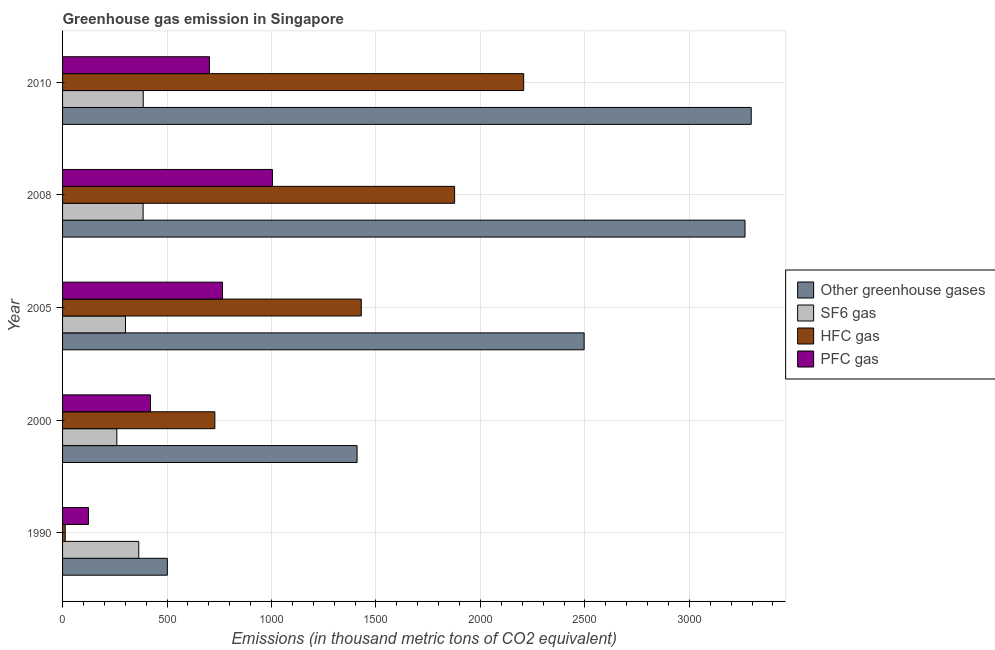How many different coloured bars are there?
Your answer should be very brief. 4. How many bars are there on the 4th tick from the bottom?
Your response must be concise. 4. What is the label of the 1st group of bars from the top?
Your answer should be very brief. 2010. In how many cases, is the number of bars for a given year not equal to the number of legend labels?
Your answer should be very brief. 0. What is the emission of hfc gas in 2008?
Offer a very short reply. 1876.4. Across all years, what is the maximum emission of pfc gas?
Provide a short and direct response. 1004.5. Across all years, what is the minimum emission of greenhouse gases?
Make the answer very short. 501.5. What is the total emission of hfc gas in the graph?
Your answer should be very brief. 6254.6. What is the difference between the emission of sf6 gas in 1990 and that in 2010?
Keep it short and to the point. -21.3. What is the difference between the emission of pfc gas in 2010 and the emission of hfc gas in 2008?
Your response must be concise. -1173.4. What is the average emission of sf6 gas per year?
Offer a terse response. 339.44. In the year 2008, what is the difference between the emission of greenhouse gases and emission of hfc gas?
Your response must be concise. 1390. In how many years, is the emission of sf6 gas greater than 2800 thousand metric tons?
Make the answer very short. 0. What is the ratio of the emission of hfc gas in 1990 to that in 2005?
Provide a succinct answer. 0.01. Is the difference between the emission of pfc gas in 2005 and 2008 greater than the difference between the emission of sf6 gas in 2005 and 2008?
Provide a succinct answer. No. What is the difference between the highest and the second highest emission of greenhouse gases?
Your answer should be very brief. 29.6. What is the difference between the highest and the lowest emission of greenhouse gases?
Your response must be concise. 2794.5. In how many years, is the emission of pfc gas greater than the average emission of pfc gas taken over all years?
Your answer should be very brief. 3. Is the sum of the emission of hfc gas in 2000 and 2010 greater than the maximum emission of sf6 gas across all years?
Provide a succinct answer. Yes. What does the 4th bar from the top in 2008 represents?
Provide a short and direct response. Other greenhouse gases. What does the 3rd bar from the bottom in 2005 represents?
Provide a succinct answer. HFC gas. Is it the case that in every year, the sum of the emission of greenhouse gases and emission of sf6 gas is greater than the emission of hfc gas?
Offer a very short reply. Yes. What is the title of the graph?
Keep it short and to the point. Greenhouse gas emission in Singapore. Does "WHO" appear as one of the legend labels in the graph?
Offer a terse response. No. What is the label or title of the X-axis?
Provide a succinct answer. Emissions (in thousand metric tons of CO2 equivalent). What is the Emissions (in thousand metric tons of CO2 equivalent) of Other greenhouse gases in 1990?
Your response must be concise. 501.5. What is the Emissions (in thousand metric tons of CO2 equivalent) of SF6 gas in 1990?
Offer a terse response. 364.7. What is the Emissions (in thousand metric tons of CO2 equivalent) of HFC gas in 1990?
Provide a short and direct response. 12.6. What is the Emissions (in thousand metric tons of CO2 equivalent) in PFC gas in 1990?
Your answer should be compact. 124.2. What is the Emissions (in thousand metric tons of CO2 equivalent) in Other greenhouse gases in 2000?
Keep it short and to the point. 1409.6. What is the Emissions (in thousand metric tons of CO2 equivalent) of SF6 gas in 2000?
Offer a terse response. 259.8. What is the Emissions (in thousand metric tons of CO2 equivalent) of HFC gas in 2000?
Make the answer very short. 728.9. What is the Emissions (in thousand metric tons of CO2 equivalent) in PFC gas in 2000?
Give a very brief answer. 420.9. What is the Emissions (in thousand metric tons of CO2 equivalent) in Other greenhouse gases in 2005?
Your answer should be very brief. 2496.4. What is the Emissions (in thousand metric tons of CO2 equivalent) in SF6 gas in 2005?
Ensure brevity in your answer.  301.2. What is the Emissions (in thousand metric tons of CO2 equivalent) in HFC gas in 2005?
Make the answer very short. 1429.7. What is the Emissions (in thousand metric tons of CO2 equivalent) in PFC gas in 2005?
Make the answer very short. 765.5. What is the Emissions (in thousand metric tons of CO2 equivalent) in Other greenhouse gases in 2008?
Give a very brief answer. 3266.4. What is the Emissions (in thousand metric tons of CO2 equivalent) of SF6 gas in 2008?
Provide a short and direct response. 385.5. What is the Emissions (in thousand metric tons of CO2 equivalent) of HFC gas in 2008?
Your answer should be very brief. 1876.4. What is the Emissions (in thousand metric tons of CO2 equivalent) in PFC gas in 2008?
Provide a short and direct response. 1004.5. What is the Emissions (in thousand metric tons of CO2 equivalent) in Other greenhouse gases in 2010?
Provide a succinct answer. 3296. What is the Emissions (in thousand metric tons of CO2 equivalent) of SF6 gas in 2010?
Offer a very short reply. 386. What is the Emissions (in thousand metric tons of CO2 equivalent) in HFC gas in 2010?
Your response must be concise. 2207. What is the Emissions (in thousand metric tons of CO2 equivalent) in PFC gas in 2010?
Keep it short and to the point. 703. Across all years, what is the maximum Emissions (in thousand metric tons of CO2 equivalent) in Other greenhouse gases?
Ensure brevity in your answer.  3296. Across all years, what is the maximum Emissions (in thousand metric tons of CO2 equivalent) in SF6 gas?
Offer a terse response. 386. Across all years, what is the maximum Emissions (in thousand metric tons of CO2 equivalent) in HFC gas?
Your response must be concise. 2207. Across all years, what is the maximum Emissions (in thousand metric tons of CO2 equivalent) of PFC gas?
Keep it short and to the point. 1004.5. Across all years, what is the minimum Emissions (in thousand metric tons of CO2 equivalent) of Other greenhouse gases?
Offer a terse response. 501.5. Across all years, what is the minimum Emissions (in thousand metric tons of CO2 equivalent) in SF6 gas?
Ensure brevity in your answer.  259.8. Across all years, what is the minimum Emissions (in thousand metric tons of CO2 equivalent) in HFC gas?
Your answer should be compact. 12.6. Across all years, what is the minimum Emissions (in thousand metric tons of CO2 equivalent) in PFC gas?
Offer a very short reply. 124.2. What is the total Emissions (in thousand metric tons of CO2 equivalent) of Other greenhouse gases in the graph?
Give a very brief answer. 1.10e+04. What is the total Emissions (in thousand metric tons of CO2 equivalent) in SF6 gas in the graph?
Provide a succinct answer. 1697.2. What is the total Emissions (in thousand metric tons of CO2 equivalent) in HFC gas in the graph?
Give a very brief answer. 6254.6. What is the total Emissions (in thousand metric tons of CO2 equivalent) of PFC gas in the graph?
Your response must be concise. 3018.1. What is the difference between the Emissions (in thousand metric tons of CO2 equivalent) in Other greenhouse gases in 1990 and that in 2000?
Offer a terse response. -908.1. What is the difference between the Emissions (in thousand metric tons of CO2 equivalent) of SF6 gas in 1990 and that in 2000?
Your response must be concise. 104.9. What is the difference between the Emissions (in thousand metric tons of CO2 equivalent) of HFC gas in 1990 and that in 2000?
Give a very brief answer. -716.3. What is the difference between the Emissions (in thousand metric tons of CO2 equivalent) of PFC gas in 1990 and that in 2000?
Your response must be concise. -296.7. What is the difference between the Emissions (in thousand metric tons of CO2 equivalent) in Other greenhouse gases in 1990 and that in 2005?
Offer a very short reply. -1994.9. What is the difference between the Emissions (in thousand metric tons of CO2 equivalent) in SF6 gas in 1990 and that in 2005?
Ensure brevity in your answer.  63.5. What is the difference between the Emissions (in thousand metric tons of CO2 equivalent) of HFC gas in 1990 and that in 2005?
Your answer should be very brief. -1417.1. What is the difference between the Emissions (in thousand metric tons of CO2 equivalent) in PFC gas in 1990 and that in 2005?
Your response must be concise. -641.3. What is the difference between the Emissions (in thousand metric tons of CO2 equivalent) in Other greenhouse gases in 1990 and that in 2008?
Your answer should be compact. -2764.9. What is the difference between the Emissions (in thousand metric tons of CO2 equivalent) in SF6 gas in 1990 and that in 2008?
Provide a short and direct response. -20.8. What is the difference between the Emissions (in thousand metric tons of CO2 equivalent) in HFC gas in 1990 and that in 2008?
Give a very brief answer. -1863.8. What is the difference between the Emissions (in thousand metric tons of CO2 equivalent) of PFC gas in 1990 and that in 2008?
Your answer should be compact. -880.3. What is the difference between the Emissions (in thousand metric tons of CO2 equivalent) of Other greenhouse gases in 1990 and that in 2010?
Keep it short and to the point. -2794.5. What is the difference between the Emissions (in thousand metric tons of CO2 equivalent) in SF6 gas in 1990 and that in 2010?
Your answer should be very brief. -21.3. What is the difference between the Emissions (in thousand metric tons of CO2 equivalent) of HFC gas in 1990 and that in 2010?
Offer a terse response. -2194.4. What is the difference between the Emissions (in thousand metric tons of CO2 equivalent) of PFC gas in 1990 and that in 2010?
Ensure brevity in your answer.  -578.8. What is the difference between the Emissions (in thousand metric tons of CO2 equivalent) of Other greenhouse gases in 2000 and that in 2005?
Ensure brevity in your answer.  -1086.8. What is the difference between the Emissions (in thousand metric tons of CO2 equivalent) in SF6 gas in 2000 and that in 2005?
Ensure brevity in your answer.  -41.4. What is the difference between the Emissions (in thousand metric tons of CO2 equivalent) of HFC gas in 2000 and that in 2005?
Give a very brief answer. -700.8. What is the difference between the Emissions (in thousand metric tons of CO2 equivalent) in PFC gas in 2000 and that in 2005?
Your response must be concise. -344.6. What is the difference between the Emissions (in thousand metric tons of CO2 equivalent) of Other greenhouse gases in 2000 and that in 2008?
Offer a very short reply. -1856.8. What is the difference between the Emissions (in thousand metric tons of CO2 equivalent) of SF6 gas in 2000 and that in 2008?
Offer a terse response. -125.7. What is the difference between the Emissions (in thousand metric tons of CO2 equivalent) of HFC gas in 2000 and that in 2008?
Give a very brief answer. -1147.5. What is the difference between the Emissions (in thousand metric tons of CO2 equivalent) in PFC gas in 2000 and that in 2008?
Make the answer very short. -583.6. What is the difference between the Emissions (in thousand metric tons of CO2 equivalent) in Other greenhouse gases in 2000 and that in 2010?
Your answer should be very brief. -1886.4. What is the difference between the Emissions (in thousand metric tons of CO2 equivalent) of SF6 gas in 2000 and that in 2010?
Your answer should be compact. -126.2. What is the difference between the Emissions (in thousand metric tons of CO2 equivalent) in HFC gas in 2000 and that in 2010?
Your answer should be very brief. -1478.1. What is the difference between the Emissions (in thousand metric tons of CO2 equivalent) in PFC gas in 2000 and that in 2010?
Your answer should be very brief. -282.1. What is the difference between the Emissions (in thousand metric tons of CO2 equivalent) of Other greenhouse gases in 2005 and that in 2008?
Offer a very short reply. -770. What is the difference between the Emissions (in thousand metric tons of CO2 equivalent) in SF6 gas in 2005 and that in 2008?
Give a very brief answer. -84.3. What is the difference between the Emissions (in thousand metric tons of CO2 equivalent) in HFC gas in 2005 and that in 2008?
Provide a short and direct response. -446.7. What is the difference between the Emissions (in thousand metric tons of CO2 equivalent) of PFC gas in 2005 and that in 2008?
Keep it short and to the point. -239. What is the difference between the Emissions (in thousand metric tons of CO2 equivalent) of Other greenhouse gases in 2005 and that in 2010?
Provide a short and direct response. -799.6. What is the difference between the Emissions (in thousand metric tons of CO2 equivalent) of SF6 gas in 2005 and that in 2010?
Your response must be concise. -84.8. What is the difference between the Emissions (in thousand metric tons of CO2 equivalent) in HFC gas in 2005 and that in 2010?
Ensure brevity in your answer.  -777.3. What is the difference between the Emissions (in thousand metric tons of CO2 equivalent) in PFC gas in 2005 and that in 2010?
Make the answer very short. 62.5. What is the difference between the Emissions (in thousand metric tons of CO2 equivalent) in Other greenhouse gases in 2008 and that in 2010?
Make the answer very short. -29.6. What is the difference between the Emissions (in thousand metric tons of CO2 equivalent) in SF6 gas in 2008 and that in 2010?
Your answer should be very brief. -0.5. What is the difference between the Emissions (in thousand metric tons of CO2 equivalent) of HFC gas in 2008 and that in 2010?
Make the answer very short. -330.6. What is the difference between the Emissions (in thousand metric tons of CO2 equivalent) of PFC gas in 2008 and that in 2010?
Offer a very short reply. 301.5. What is the difference between the Emissions (in thousand metric tons of CO2 equivalent) in Other greenhouse gases in 1990 and the Emissions (in thousand metric tons of CO2 equivalent) in SF6 gas in 2000?
Ensure brevity in your answer.  241.7. What is the difference between the Emissions (in thousand metric tons of CO2 equivalent) of Other greenhouse gases in 1990 and the Emissions (in thousand metric tons of CO2 equivalent) of HFC gas in 2000?
Ensure brevity in your answer.  -227.4. What is the difference between the Emissions (in thousand metric tons of CO2 equivalent) of Other greenhouse gases in 1990 and the Emissions (in thousand metric tons of CO2 equivalent) of PFC gas in 2000?
Your answer should be very brief. 80.6. What is the difference between the Emissions (in thousand metric tons of CO2 equivalent) of SF6 gas in 1990 and the Emissions (in thousand metric tons of CO2 equivalent) of HFC gas in 2000?
Offer a very short reply. -364.2. What is the difference between the Emissions (in thousand metric tons of CO2 equivalent) in SF6 gas in 1990 and the Emissions (in thousand metric tons of CO2 equivalent) in PFC gas in 2000?
Your answer should be very brief. -56.2. What is the difference between the Emissions (in thousand metric tons of CO2 equivalent) of HFC gas in 1990 and the Emissions (in thousand metric tons of CO2 equivalent) of PFC gas in 2000?
Ensure brevity in your answer.  -408.3. What is the difference between the Emissions (in thousand metric tons of CO2 equivalent) of Other greenhouse gases in 1990 and the Emissions (in thousand metric tons of CO2 equivalent) of SF6 gas in 2005?
Your response must be concise. 200.3. What is the difference between the Emissions (in thousand metric tons of CO2 equivalent) in Other greenhouse gases in 1990 and the Emissions (in thousand metric tons of CO2 equivalent) in HFC gas in 2005?
Ensure brevity in your answer.  -928.2. What is the difference between the Emissions (in thousand metric tons of CO2 equivalent) in Other greenhouse gases in 1990 and the Emissions (in thousand metric tons of CO2 equivalent) in PFC gas in 2005?
Provide a succinct answer. -264. What is the difference between the Emissions (in thousand metric tons of CO2 equivalent) of SF6 gas in 1990 and the Emissions (in thousand metric tons of CO2 equivalent) of HFC gas in 2005?
Provide a succinct answer. -1065. What is the difference between the Emissions (in thousand metric tons of CO2 equivalent) in SF6 gas in 1990 and the Emissions (in thousand metric tons of CO2 equivalent) in PFC gas in 2005?
Give a very brief answer. -400.8. What is the difference between the Emissions (in thousand metric tons of CO2 equivalent) of HFC gas in 1990 and the Emissions (in thousand metric tons of CO2 equivalent) of PFC gas in 2005?
Keep it short and to the point. -752.9. What is the difference between the Emissions (in thousand metric tons of CO2 equivalent) of Other greenhouse gases in 1990 and the Emissions (in thousand metric tons of CO2 equivalent) of SF6 gas in 2008?
Your answer should be very brief. 116. What is the difference between the Emissions (in thousand metric tons of CO2 equivalent) in Other greenhouse gases in 1990 and the Emissions (in thousand metric tons of CO2 equivalent) in HFC gas in 2008?
Offer a very short reply. -1374.9. What is the difference between the Emissions (in thousand metric tons of CO2 equivalent) in Other greenhouse gases in 1990 and the Emissions (in thousand metric tons of CO2 equivalent) in PFC gas in 2008?
Provide a short and direct response. -503. What is the difference between the Emissions (in thousand metric tons of CO2 equivalent) of SF6 gas in 1990 and the Emissions (in thousand metric tons of CO2 equivalent) of HFC gas in 2008?
Your response must be concise. -1511.7. What is the difference between the Emissions (in thousand metric tons of CO2 equivalent) of SF6 gas in 1990 and the Emissions (in thousand metric tons of CO2 equivalent) of PFC gas in 2008?
Offer a terse response. -639.8. What is the difference between the Emissions (in thousand metric tons of CO2 equivalent) in HFC gas in 1990 and the Emissions (in thousand metric tons of CO2 equivalent) in PFC gas in 2008?
Your answer should be very brief. -991.9. What is the difference between the Emissions (in thousand metric tons of CO2 equivalent) in Other greenhouse gases in 1990 and the Emissions (in thousand metric tons of CO2 equivalent) in SF6 gas in 2010?
Keep it short and to the point. 115.5. What is the difference between the Emissions (in thousand metric tons of CO2 equivalent) of Other greenhouse gases in 1990 and the Emissions (in thousand metric tons of CO2 equivalent) of HFC gas in 2010?
Provide a succinct answer. -1705.5. What is the difference between the Emissions (in thousand metric tons of CO2 equivalent) in Other greenhouse gases in 1990 and the Emissions (in thousand metric tons of CO2 equivalent) in PFC gas in 2010?
Make the answer very short. -201.5. What is the difference between the Emissions (in thousand metric tons of CO2 equivalent) in SF6 gas in 1990 and the Emissions (in thousand metric tons of CO2 equivalent) in HFC gas in 2010?
Provide a succinct answer. -1842.3. What is the difference between the Emissions (in thousand metric tons of CO2 equivalent) in SF6 gas in 1990 and the Emissions (in thousand metric tons of CO2 equivalent) in PFC gas in 2010?
Offer a very short reply. -338.3. What is the difference between the Emissions (in thousand metric tons of CO2 equivalent) of HFC gas in 1990 and the Emissions (in thousand metric tons of CO2 equivalent) of PFC gas in 2010?
Give a very brief answer. -690.4. What is the difference between the Emissions (in thousand metric tons of CO2 equivalent) in Other greenhouse gases in 2000 and the Emissions (in thousand metric tons of CO2 equivalent) in SF6 gas in 2005?
Your response must be concise. 1108.4. What is the difference between the Emissions (in thousand metric tons of CO2 equivalent) of Other greenhouse gases in 2000 and the Emissions (in thousand metric tons of CO2 equivalent) of HFC gas in 2005?
Provide a succinct answer. -20.1. What is the difference between the Emissions (in thousand metric tons of CO2 equivalent) of Other greenhouse gases in 2000 and the Emissions (in thousand metric tons of CO2 equivalent) of PFC gas in 2005?
Ensure brevity in your answer.  644.1. What is the difference between the Emissions (in thousand metric tons of CO2 equivalent) in SF6 gas in 2000 and the Emissions (in thousand metric tons of CO2 equivalent) in HFC gas in 2005?
Provide a short and direct response. -1169.9. What is the difference between the Emissions (in thousand metric tons of CO2 equivalent) in SF6 gas in 2000 and the Emissions (in thousand metric tons of CO2 equivalent) in PFC gas in 2005?
Make the answer very short. -505.7. What is the difference between the Emissions (in thousand metric tons of CO2 equivalent) of HFC gas in 2000 and the Emissions (in thousand metric tons of CO2 equivalent) of PFC gas in 2005?
Offer a terse response. -36.6. What is the difference between the Emissions (in thousand metric tons of CO2 equivalent) in Other greenhouse gases in 2000 and the Emissions (in thousand metric tons of CO2 equivalent) in SF6 gas in 2008?
Offer a very short reply. 1024.1. What is the difference between the Emissions (in thousand metric tons of CO2 equivalent) of Other greenhouse gases in 2000 and the Emissions (in thousand metric tons of CO2 equivalent) of HFC gas in 2008?
Make the answer very short. -466.8. What is the difference between the Emissions (in thousand metric tons of CO2 equivalent) of Other greenhouse gases in 2000 and the Emissions (in thousand metric tons of CO2 equivalent) of PFC gas in 2008?
Your answer should be compact. 405.1. What is the difference between the Emissions (in thousand metric tons of CO2 equivalent) in SF6 gas in 2000 and the Emissions (in thousand metric tons of CO2 equivalent) in HFC gas in 2008?
Make the answer very short. -1616.6. What is the difference between the Emissions (in thousand metric tons of CO2 equivalent) in SF6 gas in 2000 and the Emissions (in thousand metric tons of CO2 equivalent) in PFC gas in 2008?
Make the answer very short. -744.7. What is the difference between the Emissions (in thousand metric tons of CO2 equivalent) in HFC gas in 2000 and the Emissions (in thousand metric tons of CO2 equivalent) in PFC gas in 2008?
Keep it short and to the point. -275.6. What is the difference between the Emissions (in thousand metric tons of CO2 equivalent) of Other greenhouse gases in 2000 and the Emissions (in thousand metric tons of CO2 equivalent) of SF6 gas in 2010?
Your answer should be very brief. 1023.6. What is the difference between the Emissions (in thousand metric tons of CO2 equivalent) of Other greenhouse gases in 2000 and the Emissions (in thousand metric tons of CO2 equivalent) of HFC gas in 2010?
Give a very brief answer. -797.4. What is the difference between the Emissions (in thousand metric tons of CO2 equivalent) of Other greenhouse gases in 2000 and the Emissions (in thousand metric tons of CO2 equivalent) of PFC gas in 2010?
Keep it short and to the point. 706.6. What is the difference between the Emissions (in thousand metric tons of CO2 equivalent) in SF6 gas in 2000 and the Emissions (in thousand metric tons of CO2 equivalent) in HFC gas in 2010?
Offer a terse response. -1947.2. What is the difference between the Emissions (in thousand metric tons of CO2 equivalent) of SF6 gas in 2000 and the Emissions (in thousand metric tons of CO2 equivalent) of PFC gas in 2010?
Give a very brief answer. -443.2. What is the difference between the Emissions (in thousand metric tons of CO2 equivalent) in HFC gas in 2000 and the Emissions (in thousand metric tons of CO2 equivalent) in PFC gas in 2010?
Your response must be concise. 25.9. What is the difference between the Emissions (in thousand metric tons of CO2 equivalent) of Other greenhouse gases in 2005 and the Emissions (in thousand metric tons of CO2 equivalent) of SF6 gas in 2008?
Your answer should be compact. 2110.9. What is the difference between the Emissions (in thousand metric tons of CO2 equivalent) of Other greenhouse gases in 2005 and the Emissions (in thousand metric tons of CO2 equivalent) of HFC gas in 2008?
Provide a succinct answer. 620. What is the difference between the Emissions (in thousand metric tons of CO2 equivalent) in Other greenhouse gases in 2005 and the Emissions (in thousand metric tons of CO2 equivalent) in PFC gas in 2008?
Provide a succinct answer. 1491.9. What is the difference between the Emissions (in thousand metric tons of CO2 equivalent) in SF6 gas in 2005 and the Emissions (in thousand metric tons of CO2 equivalent) in HFC gas in 2008?
Make the answer very short. -1575.2. What is the difference between the Emissions (in thousand metric tons of CO2 equivalent) in SF6 gas in 2005 and the Emissions (in thousand metric tons of CO2 equivalent) in PFC gas in 2008?
Give a very brief answer. -703.3. What is the difference between the Emissions (in thousand metric tons of CO2 equivalent) of HFC gas in 2005 and the Emissions (in thousand metric tons of CO2 equivalent) of PFC gas in 2008?
Offer a terse response. 425.2. What is the difference between the Emissions (in thousand metric tons of CO2 equivalent) of Other greenhouse gases in 2005 and the Emissions (in thousand metric tons of CO2 equivalent) of SF6 gas in 2010?
Make the answer very short. 2110.4. What is the difference between the Emissions (in thousand metric tons of CO2 equivalent) in Other greenhouse gases in 2005 and the Emissions (in thousand metric tons of CO2 equivalent) in HFC gas in 2010?
Ensure brevity in your answer.  289.4. What is the difference between the Emissions (in thousand metric tons of CO2 equivalent) in Other greenhouse gases in 2005 and the Emissions (in thousand metric tons of CO2 equivalent) in PFC gas in 2010?
Provide a succinct answer. 1793.4. What is the difference between the Emissions (in thousand metric tons of CO2 equivalent) of SF6 gas in 2005 and the Emissions (in thousand metric tons of CO2 equivalent) of HFC gas in 2010?
Make the answer very short. -1905.8. What is the difference between the Emissions (in thousand metric tons of CO2 equivalent) in SF6 gas in 2005 and the Emissions (in thousand metric tons of CO2 equivalent) in PFC gas in 2010?
Make the answer very short. -401.8. What is the difference between the Emissions (in thousand metric tons of CO2 equivalent) of HFC gas in 2005 and the Emissions (in thousand metric tons of CO2 equivalent) of PFC gas in 2010?
Provide a short and direct response. 726.7. What is the difference between the Emissions (in thousand metric tons of CO2 equivalent) in Other greenhouse gases in 2008 and the Emissions (in thousand metric tons of CO2 equivalent) in SF6 gas in 2010?
Your response must be concise. 2880.4. What is the difference between the Emissions (in thousand metric tons of CO2 equivalent) in Other greenhouse gases in 2008 and the Emissions (in thousand metric tons of CO2 equivalent) in HFC gas in 2010?
Your answer should be very brief. 1059.4. What is the difference between the Emissions (in thousand metric tons of CO2 equivalent) of Other greenhouse gases in 2008 and the Emissions (in thousand metric tons of CO2 equivalent) of PFC gas in 2010?
Offer a very short reply. 2563.4. What is the difference between the Emissions (in thousand metric tons of CO2 equivalent) of SF6 gas in 2008 and the Emissions (in thousand metric tons of CO2 equivalent) of HFC gas in 2010?
Provide a succinct answer. -1821.5. What is the difference between the Emissions (in thousand metric tons of CO2 equivalent) in SF6 gas in 2008 and the Emissions (in thousand metric tons of CO2 equivalent) in PFC gas in 2010?
Give a very brief answer. -317.5. What is the difference between the Emissions (in thousand metric tons of CO2 equivalent) in HFC gas in 2008 and the Emissions (in thousand metric tons of CO2 equivalent) in PFC gas in 2010?
Offer a terse response. 1173.4. What is the average Emissions (in thousand metric tons of CO2 equivalent) in Other greenhouse gases per year?
Your answer should be very brief. 2193.98. What is the average Emissions (in thousand metric tons of CO2 equivalent) of SF6 gas per year?
Ensure brevity in your answer.  339.44. What is the average Emissions (in thousand metric tons of CO2 equivalent) in HFC gas per year?
Keep it short and to the point. 1250.92. What is the average Emissions (in thousand metric tons of CO2 equivalent) of PFC gas per year?
Your answer should be compact. 603.62. In the year 1990, what is the difference between the Emissions (in thousand metric tons of CO2 equivalent) in Other greenhouse gases and Emissions (in thousand metric tons of CO2 equivalent) in SF6 gas?
Provide a short and direct response. 136.8. In the year 1990, what is the difference between the Emissions (in thousand metric tons of CO2 equivalent) of Other greenhouse gases and Emissions (in thousand metric tons of CO2 equivalent) of HFC gas?
Your answer should be compact. 488.9. In the year 1990, what is the difference between the Emissions (in thousand metric tons of CO2 equivalent) in Other greenhouse gases and Emissions (in thousand metric tons of CO2 equivalent) in PFC gas?
Provide a short and direct response. 377.3. In the year 1990, what is the difference between the Emissions (in thousand metric tons of CO2 equivalent) of SF6 gas and Emissions (in thousand metric tons of CO2 equivalent) of HFC gas?
Provide a short and direct response. 352.1. In the year 1990, what is the difference between the Emissions (in thousand metric tons of CO2 equivalent) of SF6 gas and Emissions (in thousand metric tons of CO2 equivalent) of PFC gas?
Provide a succinct answer. 240.5. In the year 1990, what is the difference between the Emissions (in thousand metric tons of CO2 equivalent) in HFC gas and Emissions (in thousand metric tons of CO2 equivalent) in PFC gas?
Your answer should be very brief. -111.6. In the year 2000, what is the difference between the Emissions (in thousand metric tons of CO2 equivalent) of Other greenhouse gases and Emissions (in thousand metric tons of CO2 equivalent) of SF6 gas?
Offer a very short reply. 1149.8. In the year 2000, what is the difference between the Emissions (in thousand metric tons of CO2 equivalent) of Other greenhouse gases and Emissions (in thousand metric tons of CO2 equivalent) of HFC gas?
Make the answer very short. 680.7. In the year 2000, what is the difference between the Emissions (in thousand metric tons of CO2 equivalent) in Other greenhouse gases and Emissions (in thousand metric tons of CO2 equivalent) in PFC gas?
Your answer should be very brief. 988.7. In the year 2000, what is the difference between the Emissions (in thousand metric tons of CO2 equivalent) in SF6 gas and Emissions (in thousand metric tons of CO2 equivalent) in HFC gas?
Your response must be concise. -469.1. In the year 2000, what is the difference between the Emissions (in thousand metric tons of CO2 equivalent) of SF6 gas and Emissions (in thousand metric tons of CO2 equivalent) of PFC gas?
Keep it short and to the point. -161.1. In the year 2000, what is the difference between the Emissions (in thousand metric tons of CO2 equivalent) in HFC gas and Emissions (in thousand metric tons of CO2 equivalent) in PFC gas?
Your answer should be compact. 308. In the year 2005, what is the difference between the Emissions (in thousand metric tons of CO2 equivalent) of Other greenhouse gases and Emissions (in thousand metric tons of CO2 equivalent) of SF6 gas?
Offer a very short reply. 2195.2. In the year 2005, what is the difference between the Emissions (in thousand metric tons of CO2 equivalent) of Other greenhouse gases and Emissions (in thousand metric tons of CO2 equivalent) of HFC gas?
Ensure brevity in your answer.  1066.7. In the year 2005, what is the difference between the Emissions (in thousand metric tons of CO2 equivalent) in Other greenhouse gases and Emissions (in thousand metric tons of CO2 equivalent) in PFC gas?
Give a very brief answer. 1730.9. In the year 2005, what is the difference between the Emissions (in thousand metric tons of CO2 equivalent) of SF6 gas and Emissions (in thousand metric tons of CO2 equivalent) of HFC gas?
Ensure brevity in your answer.  -1128.5. In the year 2005, what is the difference between the Emissions (in thousand metric tons of CO2 equivalent) in SF6 gas and Emissions (in thousand metric tons of CO2 equivalent) in PFC gas?
Your answer should be compact. -464.3. In the year 2005, what is the difference between the Emissions (in thousand metric tons of CO2 equivalent) in HFC gas and Emissions (in thousand metric tons of CO2 equivalent) in PFC gas?
Keep it short and to the point. 664.2. In the year 2008, what is the difference between the Emissions (in thousand metric tons of CO2 equivalent) of Other greenhouse gases and Emissions (in thousand metric tons of CO2 equivalent) of SF6 gas?
Ensure brevity in your answer.  2880.9. In the year 2008, what is the difference between the Emissions (in thousand metric tons of CO2 equivalent) of Other greenhouse gases and Emissions (in thousand metric tons of CO2 equivalent) of HFC gas?
Offer a terse response. 1390. In the year 2008, what is the difference between the Emissions (in thousand metric tons of CO2 equivalent) of Other greenhouse gases and Emissions (in thousand metric tons of CO2 equivalent) of PFC gas?
Your answer should be compact. 2261.9. In the year 2008, what is the difference between the Emissions (in thousand metric tons of CO2 equivalent) in SF6 gas and Emissions (in thousand metric tons of CO2 equivalent) in HFC gas?
Your answer should be compact. -1490.9. In the year 2008, what is the difference between the Emissions (in thousand metric tons of CO2 equivalent) of SF6 gas and Emissions (in thousand metric tons of CO2 equivalent) of PFC gas?
Your answer should be compact. -619. In the year 2008, what is the difference between the Emissions (in thousand metric tons of CO2 equivalent) in HFC gas and Emissions (in thousand metric tons of CO2 equivalent) in PFC gas?
Your response must be concise. 871.9. In the year 2010, what is the difference between the Emissions (in thousand metric tons of CO2 equivalent) of Other greenhouse gases and Emissions (in thousand metric tons of CO2 equivalent) of SF6 gas?
Offer a terse response. 2910. In the year 2010, what is the difference between the Emissions (in thousand metric tons of CO2 equivalent) in Other greenhouse gases and Emissions (in thousand metric tons of CO2 equivalent) in HFC gas?
Ensure brevity in your answer.  1089. In the year 2010, what is the difference between the Emissions (in thousand metric tons of CO2 equivalent) of Other greenhouse gases and Emissions (in thousand metric tons of CO2 equivalent) of PFC gas?
Offer a very short reply. 2593. In the year 2010, what is the difference between the Emissions (in thousand metric tons of CO2 equivalent) in SF6 gas and Emissions (in thousand metric tons of CO2 equivalent) in HFC gas?
Give a very brief answer. -1821. In the year 2010, what is the difference between the Emissions (in thousand metric tons of CO2 equivalent) of SF6 gas and Emissions (in thousand metric tons of CO2 equivalent) of PFC gas?
Offer a terse response. -317. In the year 2010, what is the difference between the Emissions (in thousand metric tons of CO2 equivalent) of HFC gas and Emissions (in thousand metric tons of CO2 equivalent) of PFC gas?
Your answer should be compact. 1504. What is the ratio of the Emissions (in thousand metric tons of CO2 equivalent) in Other greenhouse gases in 1990 to that in 2000?
Your response must be concise. 0.36. What is the ratio of the Emissions (in thousand metric tons of CO2 equivalent) in SF6 gas in 1990 to that in 2000?
Provide a succinct answer. 1.4. What is the ratio of the Emissions (in thousand metric tons of CO2 equivalent) in HFC gas in 1990 to that in 2000?
Make the answer very short. 0.02. What is the ratio of the Emissions (in thousand metric tons of CO2 equivalent) in PFC gas in 1990 to that in 2000?
Offer a terse response. 0.3. What is the ratio of the Emissions (in thousand metric tons of CO2 equivalent) in Other greenhouse gases in 1990 to that in 2005?
Offer a very short reply. 0.2. What is the ratio of the Emissions (in thousand metric tons of CO2 equivalent) in SF6 gas in 1990 to that in 2005?
Your answer should be compact. 1.21. What is the ratio of the Emissions (in thousand metric tons of CO2 equivalent) of HFC gas in 1990 to that in 2005?
Offer a terse response. 0.01. What is the ratio of the Emissions (in thousand metric tons of CO2 equivalent) in PFC gas in 1990 to that in 2005?
Offer a terse response. 0.16. What is the ratio of the Emissions (in thousand metric tons of CO2 equivalent) of Other greenhouse gases in 1990 to that in 2008?
Your response must be concise. 0.15. What is the ratio of the Emissions (in thousand metric tons of CO2 equivalent) of SF6 gas in 1990 to that in 2008?
Provide a succinct answer. 0.95. What is the ratio of the Emissions (in thousand metric tons of CO2 equivalent) of HFC gas in 1990 to that in 2008?
Your response must be concise. 0.01. What is the ratio of the Emissions (in thousand metric tons of CO2 equivalent) in PFC gas in 1990 to that in 2008?
Provide a short and direct response. 0.12. What is the ratio of the Emissions (in thousand metric tons of CO2 equivalent) in Other greenhouse gases in 1990 to that in 2010?
Provide a succinct answer. 0.15. What is the ratio of the Emissions (in thousand metric tons of CO2 equivalent) in SF6 gas in 1990 to that in 2010?
Ensure brevity in your answer.  0.94. What is the ratio of the Emissions (in thousand metric tons of CO2 equivalent) of HFC gas in 1990 to that in 2010?
Your response must be concise. 0.01. What is the ratio of the Emissions (in thousand metric tons of CO2 equivalent) of PFC gas in 1990 to that in 2010?
Your response must be concise. 0.18. What is the ratio of the Emissions (in thousand metric tons of CO2 equivalent) in Other greenhouse gases in 2000 to that in 2005?
Ensure brevity in your answer.  0.56. What is the ratio of the Emissions (in thousand metric tons of CO2 equivalent) in SF6 gas in 2000 to that in 2005?
Offer a terse response. 0.86. What is the ratio of the Emissions (in thousand metric tons of CO2 equivalent) of HFC gas in 2000 to that in 2005?
Keep it short and to the point. 0.51. What is the ratio of the Emissions (in thousand metric tons of CO2 equivalent) of PFC gas in 2000 to that in 2005?
Give a very brief answer. 0.55. What is the ratio of the Emissions (in thousand metric tons of CO2 equivalent) of Other greenhouse gases in 2000 to that in 2008?
Provide a succinct answer. 0.43. What is the ratio of the Emissions (in thousand metric tons of CO2 equivalent) of SF6 gas in 2000 to that in 2008?
Give a very brief answer. 0.67. What is the ratio of the Emissions (in thousand metric tons of CO2 equivalent) of HFC gas in 2000 to that in 2008?
Offer a very short reply. 0.39. What is the ratio of the Emissions (in thousand metric tons of CO2 equivalent) in PFC gas in 2000 to that in 2008?
Offer a terse response. 0.42. What is the ratio of the Emissions (in thousand metric tons of CO2 equivalent) in Other greenhouse gases in 2000 to that in 2010?
Your answer should be very brief. 0.43. What is the ratio of the Emissions (in thousand metric tons of CO2 equivalent) in SF6 gas in 2000 to that in 2010?
Your response must be concise. 0.67. What is the ratio of the Emissions (in thousand metric tons of CO2 equivalent) of HFC gas in 2000 to that in 2010?
Your response must be concise. 0.33. What is the ratio of the Emissions (in thousand metric tons of CO2 equivalent) of PFC gas in 2000 to that in 2010?
Give a very brief answer. 0.6. What is the ratio of the Emissions (in thousand metric tons of CO2 equivalent) of Other greenhouse gases in 2005 to that in 2008?
Your response must be concise. 0.76. What is the ratio of the Emissions (in thousand metric tons of CO2 equivalent) in SF6 gas in 2005 to that in 2008?
Provide a succinct answer. 0.78. What is the ratio of the Emissions (in thousand metric tons of CO2 equivalent) in HFC gas in 2005 to that in 2008?
Provide a succinct answer. 0.76. What is the ratio of the Emissions (in thousand metric tons of CO2 equivalent) in PFC gas in 2005 to that in 2008?
Provide a succinct answer. 0.76. What is the ratio of the Emissions (in thousand metric tons of CO2 equivalent) in Other greenhouse gases in 2005 to that in 2010?
Provide a short and direct response. 0.76. What is the ratio of the Emissions (in thousand metric tons of CO2 equivalent) in SF6 gas in 2005 to that in 2010?
Your answer should be compact. 0.78. What is the ratio of the Emissions (in thousand metric tons of CO2 equivalent) in HFC gas in 2005 to that in 2010?
Provide a succinct answer. 0.65. What is the ratio of the Emissions (in thousand metric tons of CO2 equivalent) of PFC gas in 2005 to that in 2010?
Provide a short and direct response. 1.09. What is the ratio of the Emissions (in thousand metric tons of CO2 equivalent) of SF6 gas in 2008 to that in 2010?
Ensure brevity in your answer.  1. What is the ratio of the Emissions (in thousand metric tons of CO2 equivalent) in HFC gas in 2008 to that in 2010?
Your answer should be compact. 0.85. What is the ratio of the Emissions (in thousand metric tons of CO2 equivalent) in PFC gas in 2008 to that in 2010?
Ensure brevity in your answer.  1.43. What is the difference between the highest and the second highest Emissions (in thousand metric tons of CO2 equivalent) in Other greenhouse gases?
Give a very brief answer. 29.6. What is the difference between the highest and the second highest Emissions (in thousand metric tons of CO2 equivalent) in HFC gas?
Your answer should be compact. 330.6. What is the difference between the highest and the second highest Emissions (in thousand metric tons of CO2 equivalent) in PFC gas?
Provide a succinct answer. 239. What is the difference between the highest and the lowest Emissions (in thousand metric tons of CO2 equivalent) in Other greenhouse gases?
Provide a short and direct response. 2794.5. What is the difference between the highest and the lowest Emissions (in thousand metric tons of CO2 equivalent) in SF6 gas?
Offer a very short reply. 126.2. What is the difference between the highest and the lowest Emissions (in thousand metric tons of CO2 equivalent) of HFC gas?
Offer a very short reply. 2194.4. What is the difference between the highest and the lowest Emissions (in thousand metric tons of CO2 equivalent) of PFC gas?
Your answer should be very brief. 880.3. 